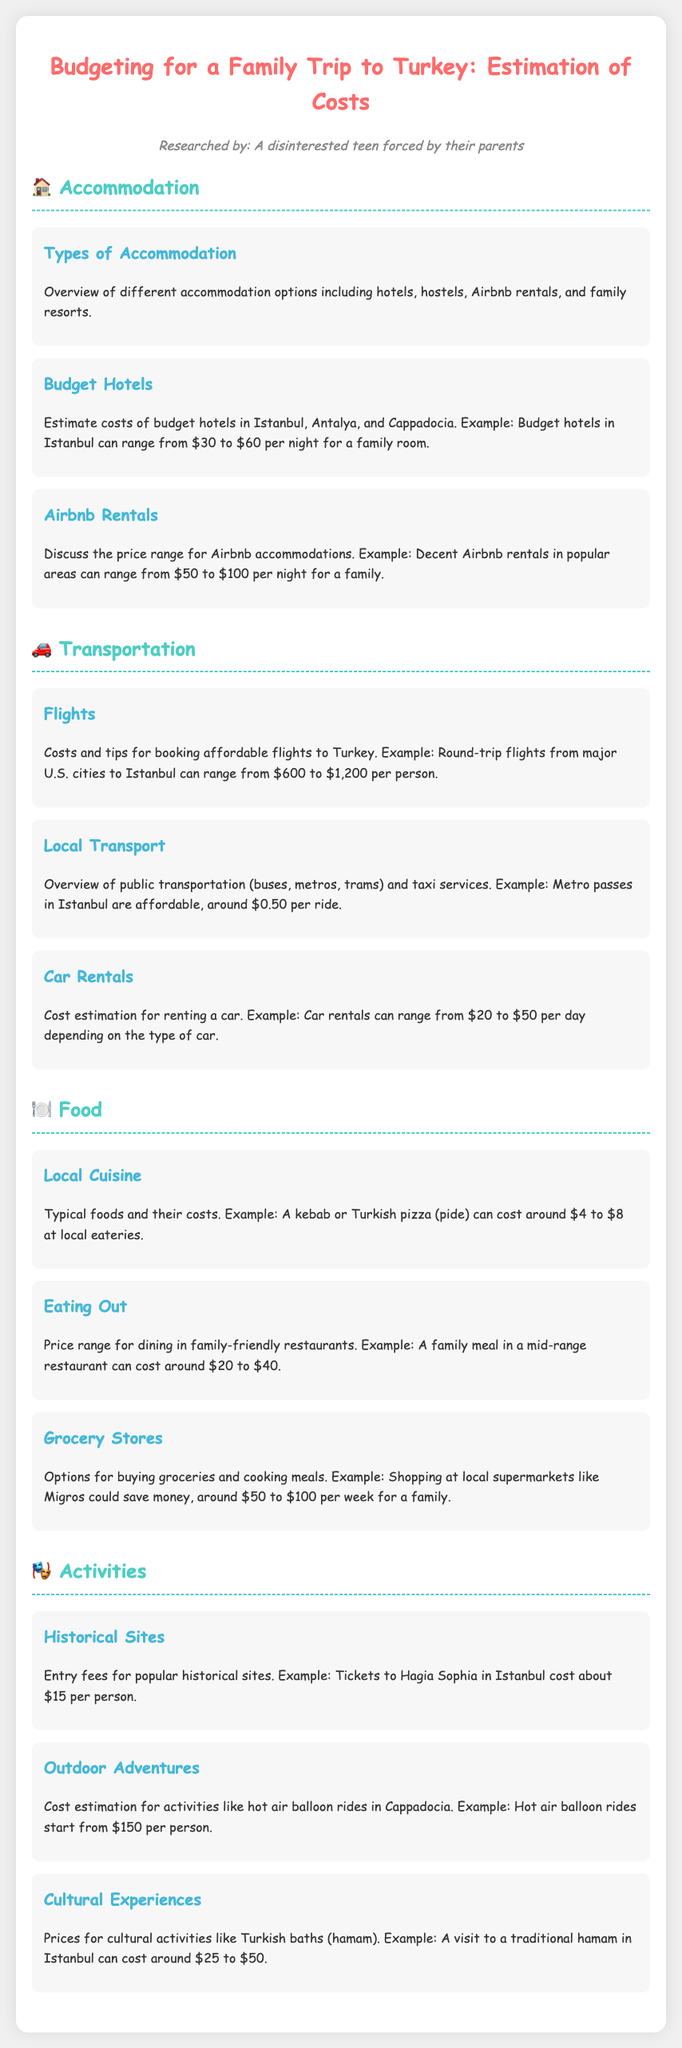What is the cost range for budget hotels in Istanbul? The document states that budget hotels in Istanbul can range from $30 to $60 per night for a family room.
Answer: $30 to $60 What is the approximate cost for a round-trip flight from major U.S. cities to Istanbul? The document indicates that round-trip flights can range from $600 to $1,200 per person.
Answer: $600 to $1,200 How much can a family meal in a mid-range restaurant cost? According to the document, a family meal in a mid-range restaurant can cost around $20 to $40.
Answer: $20 to $40 What is the estimated cost for grocery shopping at local supermarkets for a family? The document mentions that shopping at local supermarkets could cost around $50 to $100 per week for a family.
Answer: $50 to $100 How much do tickets to Hagia Sophia cost per person? The document states that tickets to Hagia Sophia in Istanbul cost about $15 per person.
Answer: $15 What is the estimated cost for hot air balloon rides in Cappadocia? The document provides that hot air balloon rides start from $150 per person.
Answer: $150 What types of accommodation options are mentioned in the document? The document lists hotels, hostels, Airbnb rentals, and family resorts as accommodation options.
Answer: Hotels, hostels, Airbnb rentals, family resorts What is the cost of a metro pass ride in Istanbul? The document states that metro passes in Istanbul are affordable, around $0.50 per ride.
Answer: $0.50 What is the price range for dining in local eateries for a kebab or Turkish pizza? The document indicates that a kebab or Turkish pizza can cost around $4 to $8 at local eateries.
Answer: $4 to $8 